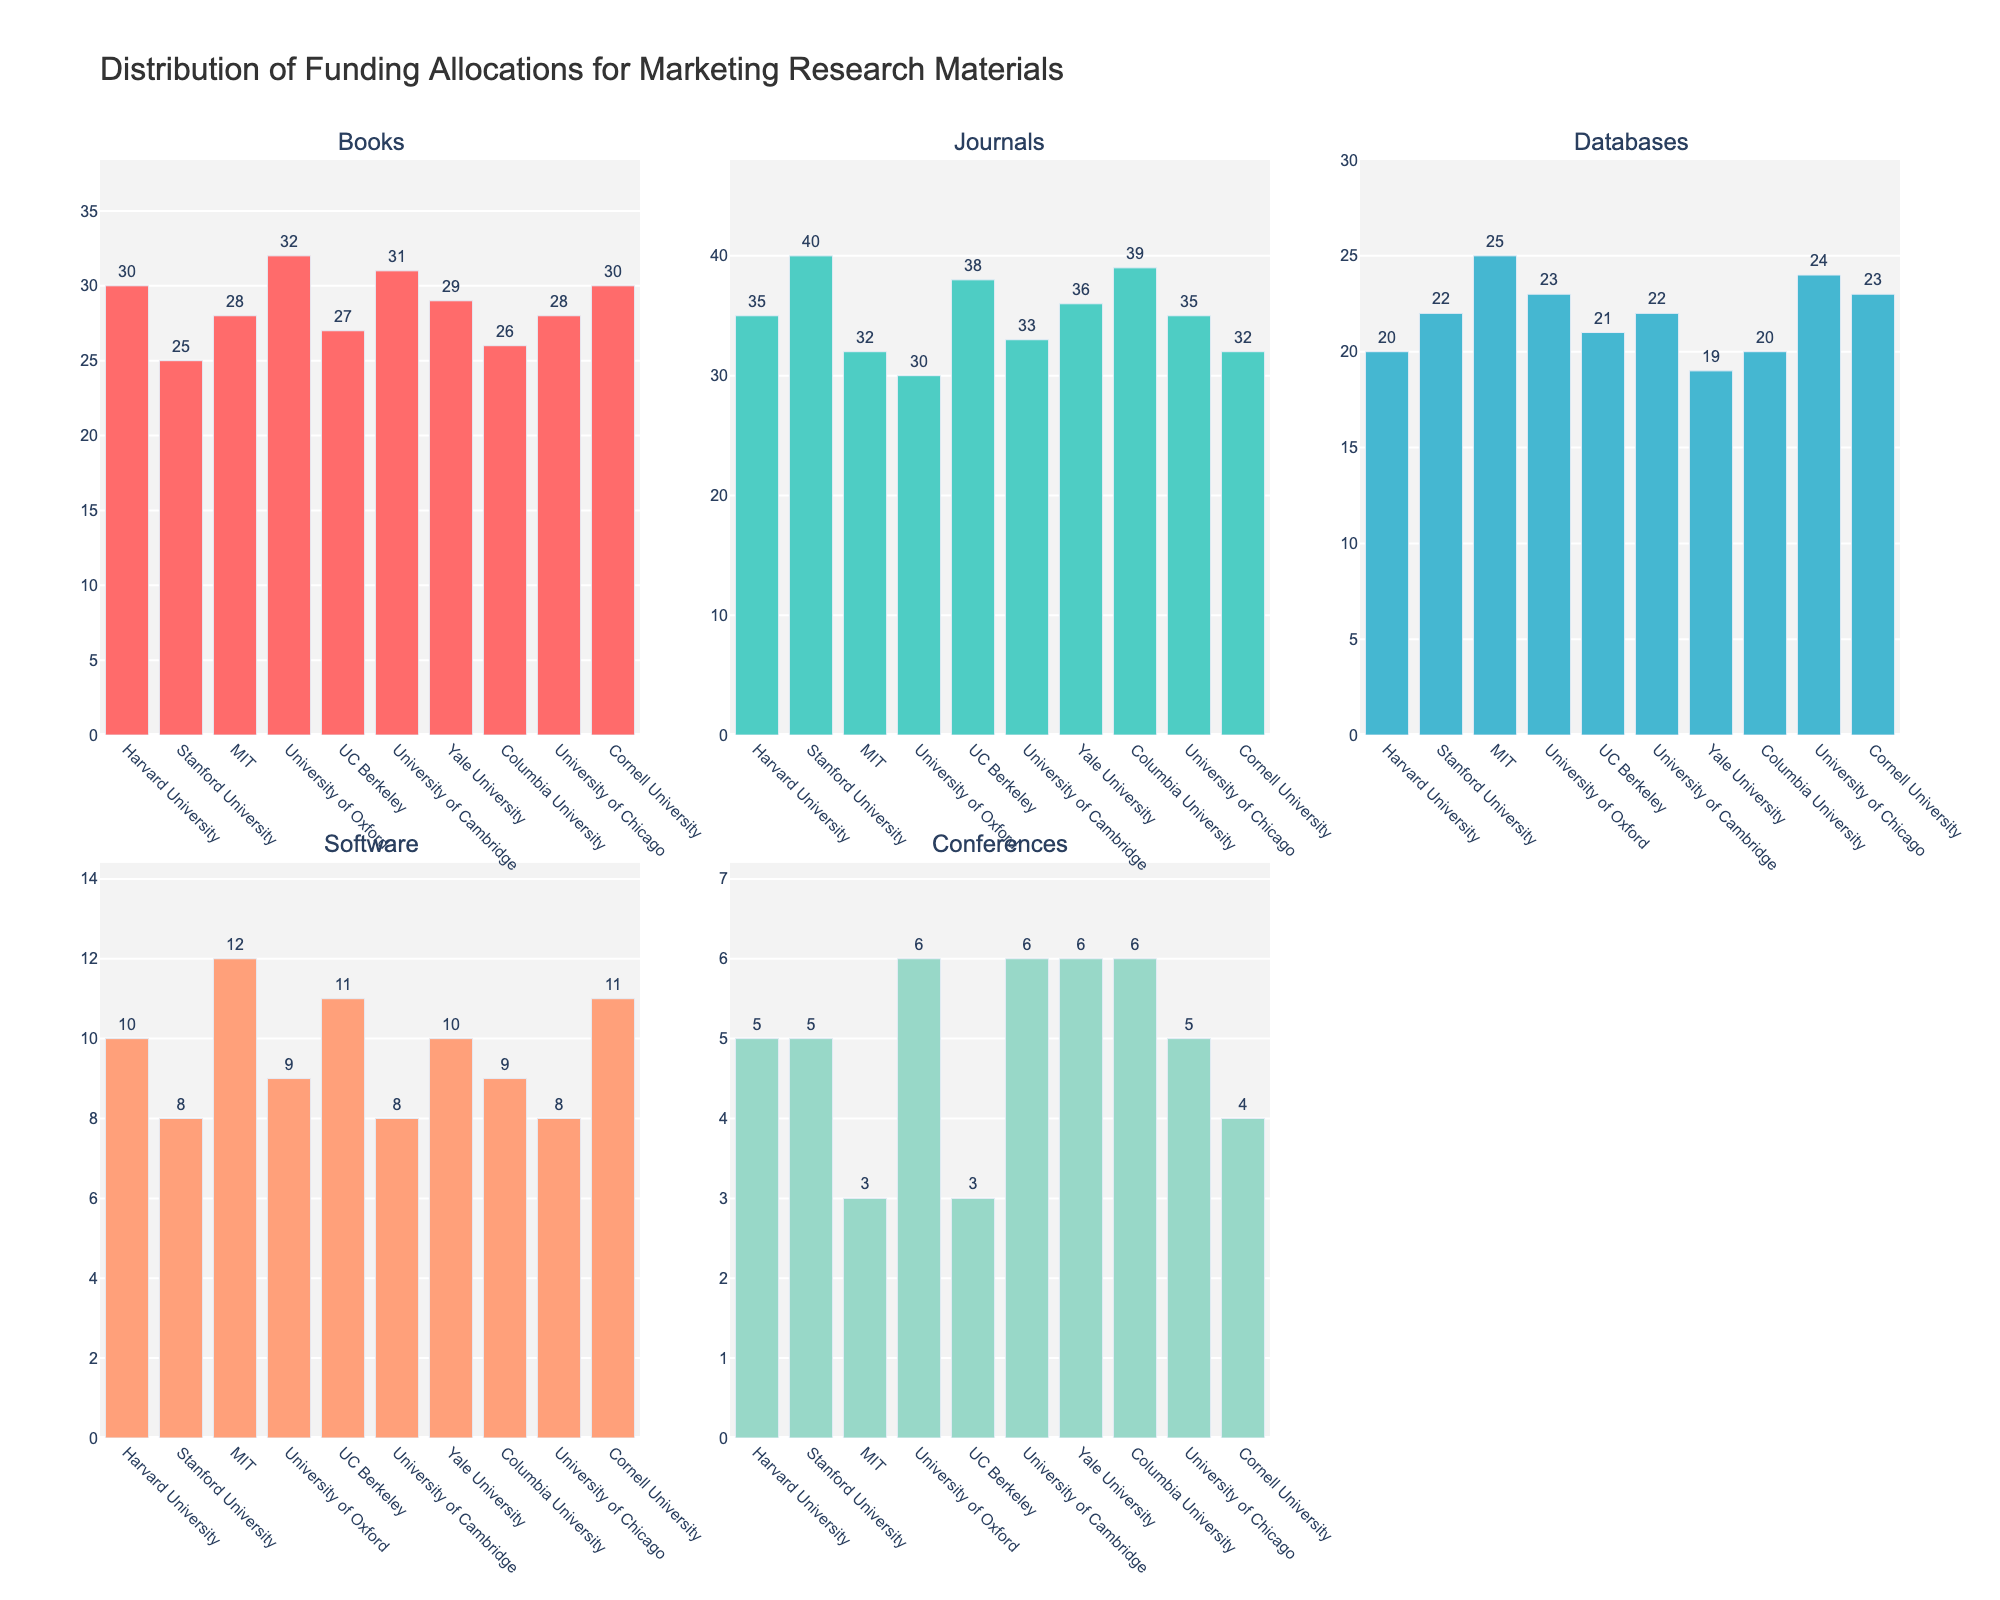What's the title of the figure? The title is prominently displayed at the top of the figure, indicating the overall theme.
Answer: "Ad Agency Revenue Trends in the 1960s" How many subplots are in the figure? By counting the individual plots, noting the subplot titles, or looking at the grid structure, we see there are six subplots.
Answer: 6 What is the revenue for the Automotive industry in 1966? Locate the point for the Automotive industry subplot at the year 1966 on the x-axis, and read its corresponding value on the y-axis.
Answer: 3.1 million dollars Which industry had the highest revenue in 1970? Compare the values for all industries in the year 1970 and find the maximum.
Answer: Tobacco What is the difference in revenue between the Alcohol and Fashion industries in 1962? Identify the revenue values in 1962 for both Alcohol (3.0 million dollars) and Fashion (1.9 million dollars) and calculate the difference.
Answer: 1.1 million dollars Which industry shows the most growth in revenue from 1960 to 1970? Calculate the difference in revenue from 1960 to 1970 for each industry and identify the largest increase.
Answer: Automotive What is the average revenue for the Consumer Goods industry across all years? Sum the revenues for Consumer Goods across all years and divide by the number of years (5.2 + 2.5 + 2.8 + 3.1 + 3.4 + 3.7).
Answer: 3.133 million dollars Did any industry show a decline in revenue at any point during the 1960s? Look for any year-to-year decreases in the revenue lines for each industry. All industries show increasing trends.
Answer: No Which industry has the smallest revenue increment between the years 1966 and 1968? Calculate the increment for each industry and identify the smallest (Automotive: 0.4, Tobacco: 0.1, Alcohol: 0.3, Fashion: 0.3, Consumer Goods: 0.3).
Answer: Tobacco 